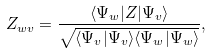<formula> <loc_0><loc_0><loc_500><loc_500>Z _ { w v } = \frac { \langle \Psi _ { w } | Z | \Psi _ { v } \rangle } { \sqrt { \langle \Psi _ { v } | \Psi _ { v } \rangle \langle \Psi _ { w } | \Psi _ { w } \rangle } } ,</formula> 